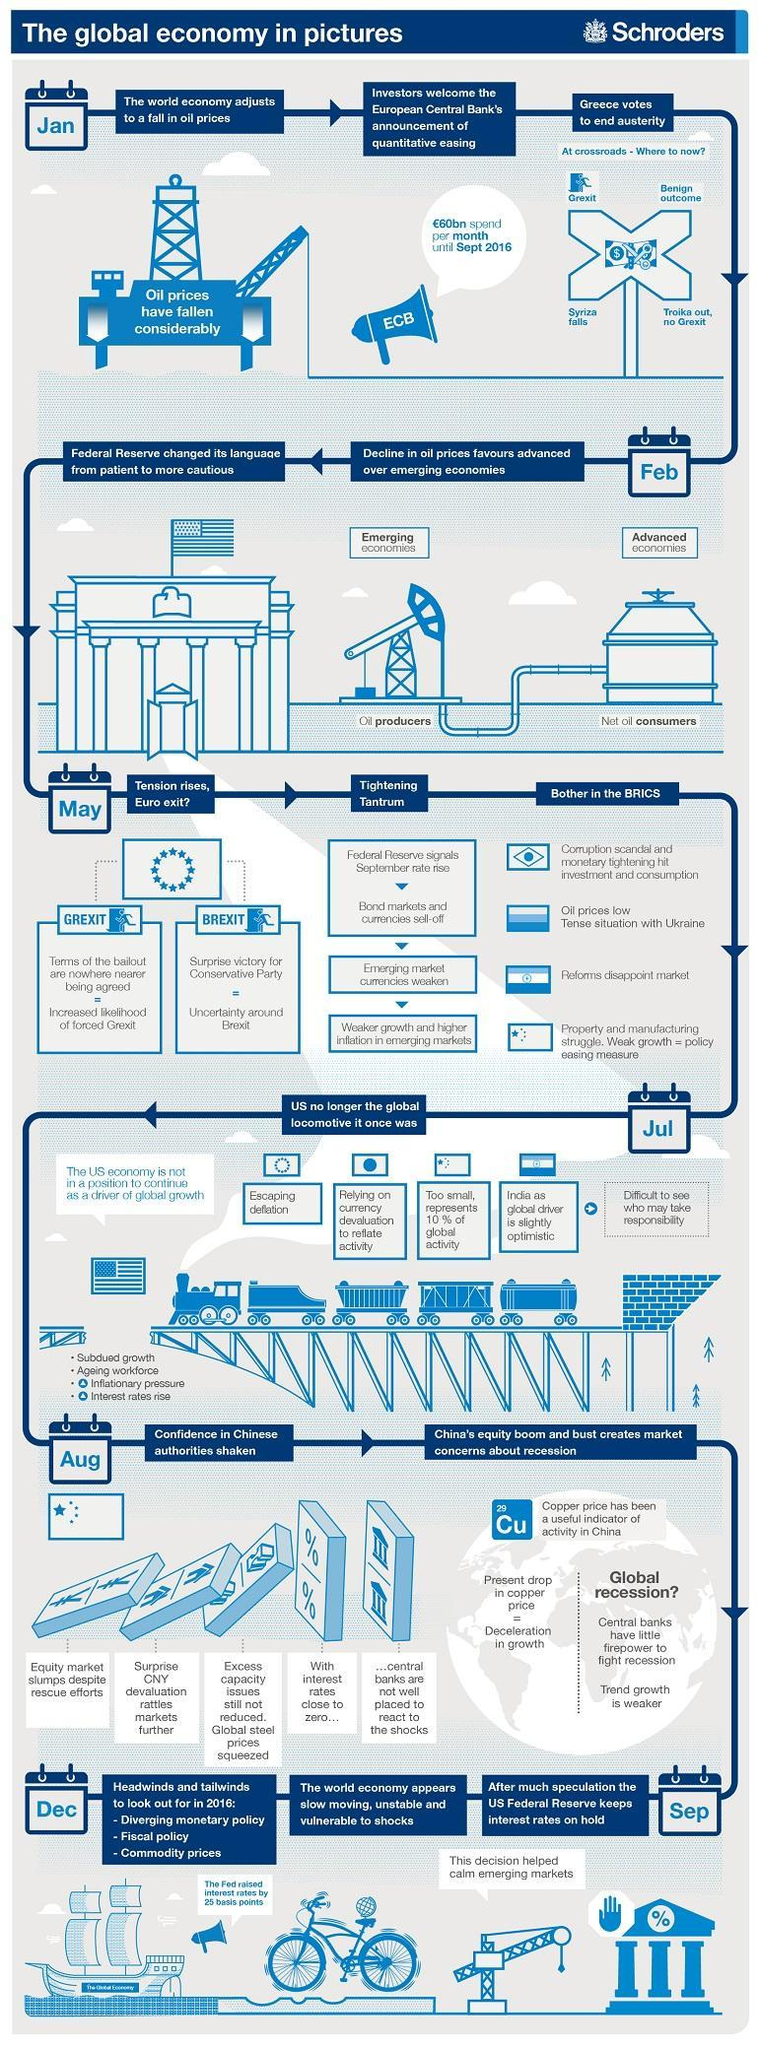When did US Economy take a back step from being the main catalyst for growth?
Answer the question with a short phrase. Jul Which was the key measure of the economic activity in China ? Copper Price Which two countries prepares for an exit from European union, Greece, US, Britain, or Ukraine? Greece, Britain Which country comes up with unsatisfactory reforms, Brazil, India, China, or Russia? India When did the key measure of China's economic growth dip? Aug Which month is Grexit initiated? Jan 